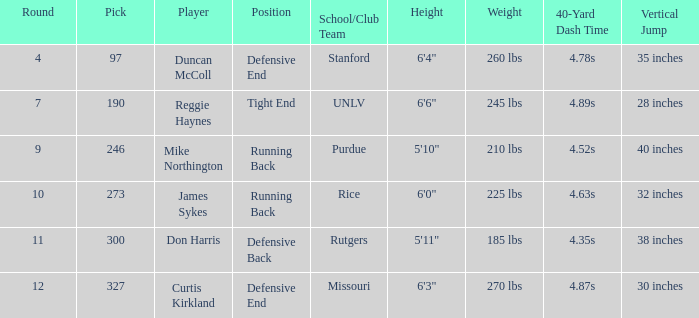What is the total number of rounds that had draft pick 97, duncan mccoll? 0.0. 